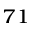<formula> <loc_0><loc_0><loc_500><loc_500>^ { 7 1 }</formula> 